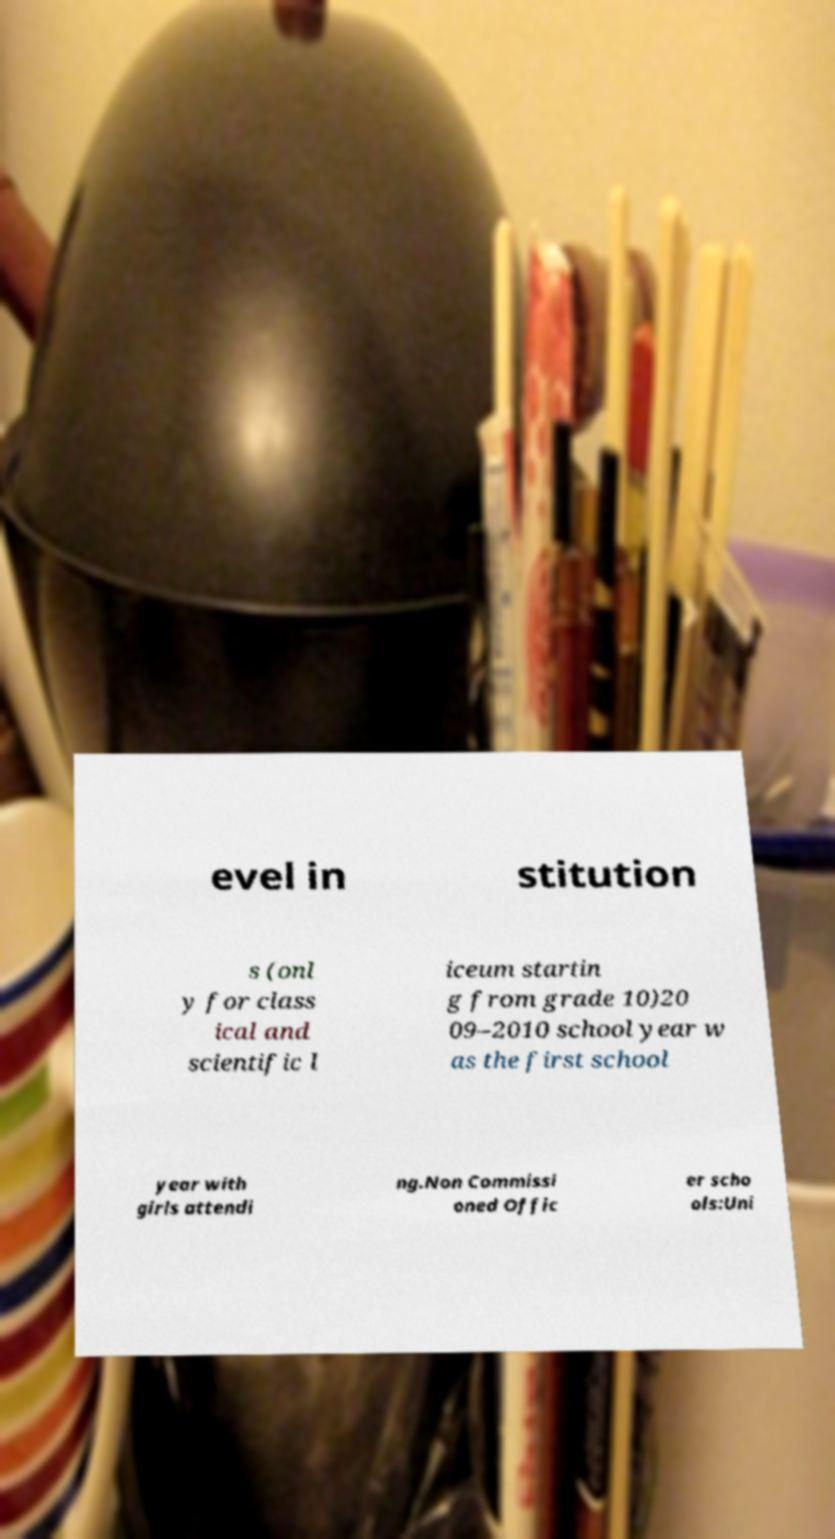I need the written content from this picture converted into text. Can you do that? evel in stitution s (onl y for class ical and scientific l iceum startin g from grade 10)20 09–2010 school year w as the first school year with girls attendi ng.Non Commissi oned Offic er scho ols:Uni 